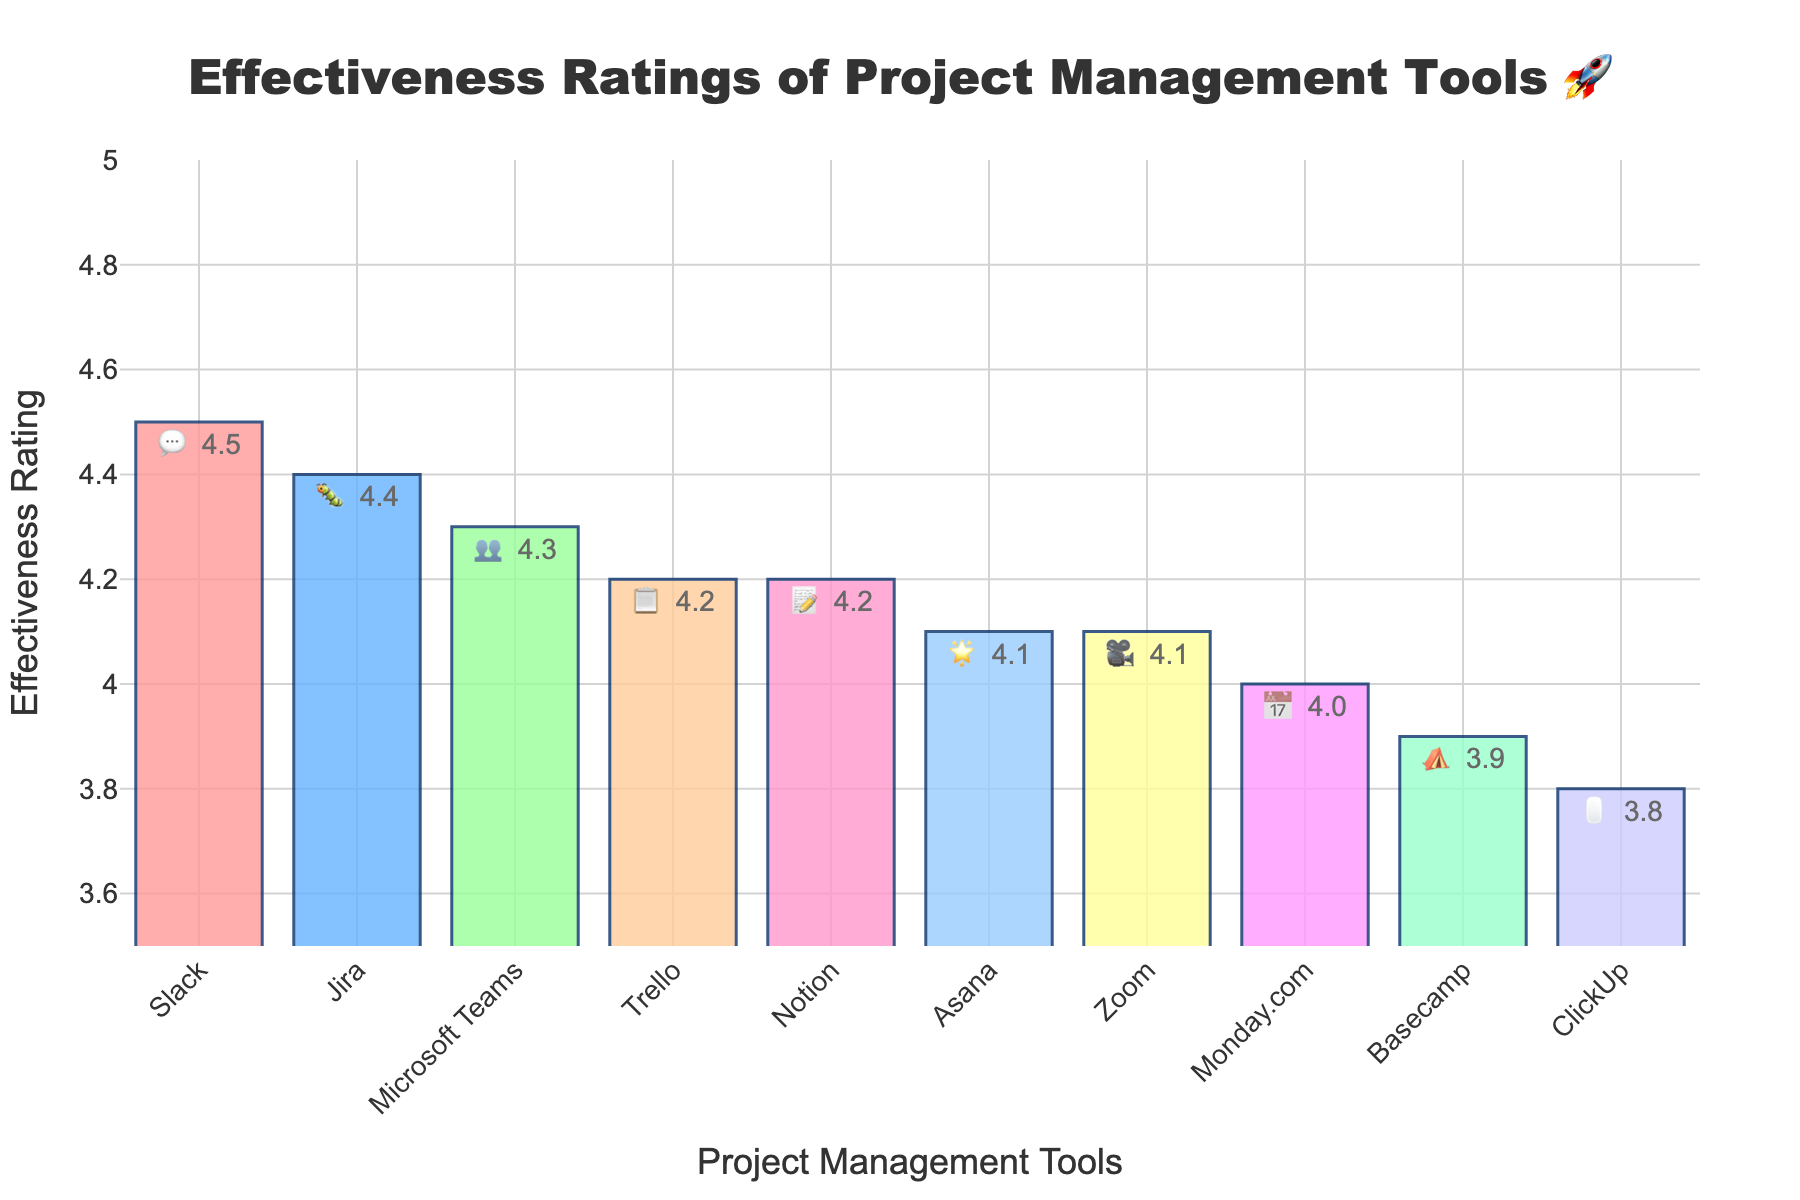Which tool has the highest effectiveness rating? The highest bar represents the tool with the highest rating, which in this case is labeled with "Slack" and has a rating of 4.5.
Answer: Slack Which tool has the lowest effectiveness rating? The lowest bar represents the tool with the lowest rating, which in this case is labeled with "ClickUp" and has a rating of 3.8.
Answer: ClickUp How many tools have an effectiveness rating of 4.0 or higher? Count the number of bars that reach or exceed the rating of 4.0. There are 8 tools with ratings equal to or higher than 4.0 (Slack, Trello, Microsoft Teams, Asana, Jira, Notion, Monday.com, Zoom).
Answer: 8 What is the difference in effectiveness rating between Slack and ClickUp? Subtract the effectiveness rating of ClickUp (3.8) from the rating of Slack (4.5). 4.5 - 3.8 = 0.7
Answer: 0.7 Which tools have the same effectiveness rating? Look for bars with identical heights and labels. Trello and Notion both have an effectiveness rating of 4.2, and Asana and Zoom both have an effectiveness rating of 4.1.
Answer: Trello and Notion, Asana and Zoom What is the average effectiveness rating of all tools? Sum all effectiveness ratings (4.5 + 4.2 + 4.3 + 4.1 + 4.4 + 3.9 + 4.0 + 4.2 + 3.8 + 4.1) and divide by the number of tools (10). The average is (41.5/10) = 4.15
Answer: 4.15 Which tool used for video conferencing has an effectiveness rating of 4.1? Identify the tool represented by the camera emoji and its rating. The tool Zoom, represented by a 🎥 emoji, has an effectiveness rating of 4.1.
Answer: Zoom Which tool represented by a star emoji has an effectiveness rating, and what is it? Look for the tool labeled with a star emoji (🌟) and find its rating. Asana, represented by the star emoji, has an effectiveness rating of 4.1.
Answer: Asana, 4.1 